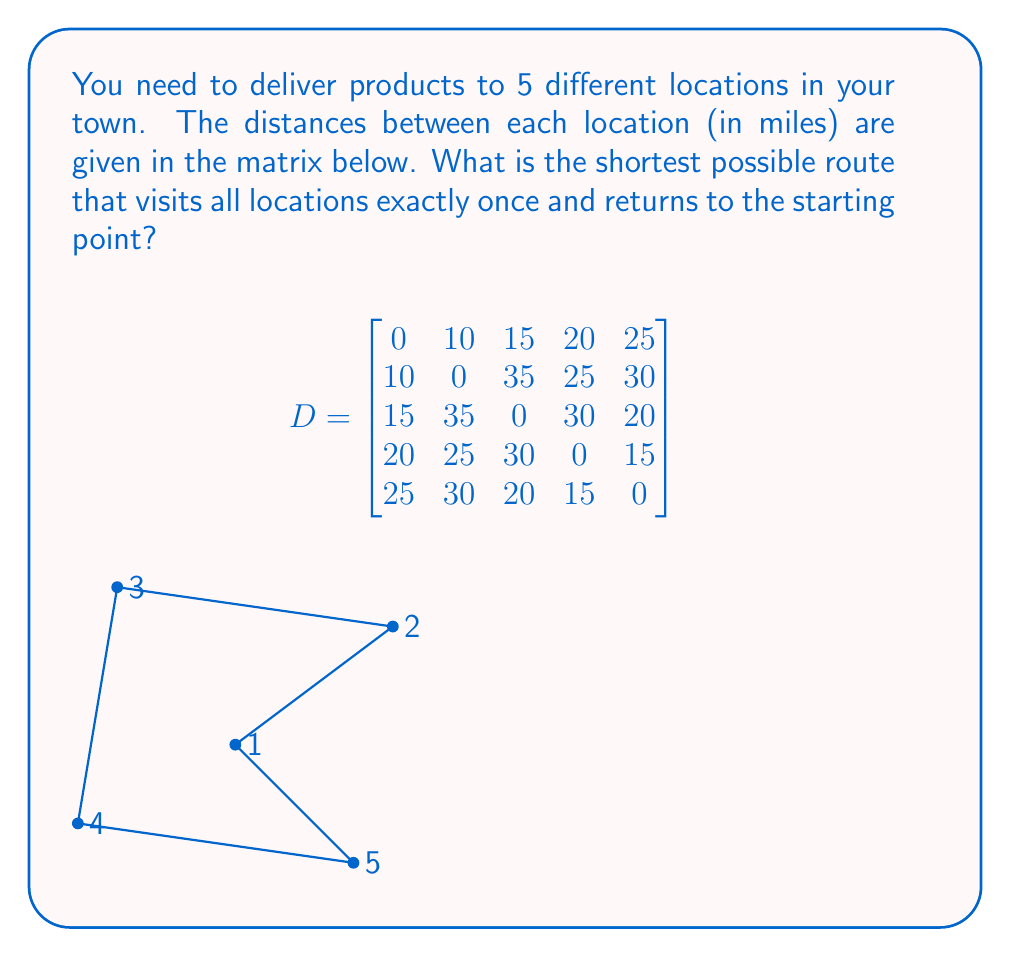Could you help me with this problem? This problem is an instance of the Traveling Salesman Problem (TSP). To solve it:

1) First, we need to list all possible routes. With 5 locations, there are $(5-1)! = 24$ possible routes.

2) For each route, calculate the total distance:
   - For example, route 1-2-3-4-5-1:
     $d_{12} + d_{23} + d_{34} + d_{45} + d_{51} = 10 + 35 + 30 + 15 + 25 = 115$ miles

3) Compare all routes to find the shortest. Here are a few:
   1-2-3-4-5-1: 115 miles
   1-2-4-3-5-1: 110 miles
   1-3-2-4-5-1: 105 miles
   1-3-5-4-2-1: 95 miles (shortest)

4) The shortest route is 1-3-5-4-2-1:
   $d_{13} + d_{35} + d_{54} + d_{42} + d_{21} = 15 + 20 + 15 + 25 + 10 = 85$ miles

This route minimizes the total distance traveled while visiting all locations once and returning to the start.
Answer: 85 miles (route: 1-3-5-4-2-1) 